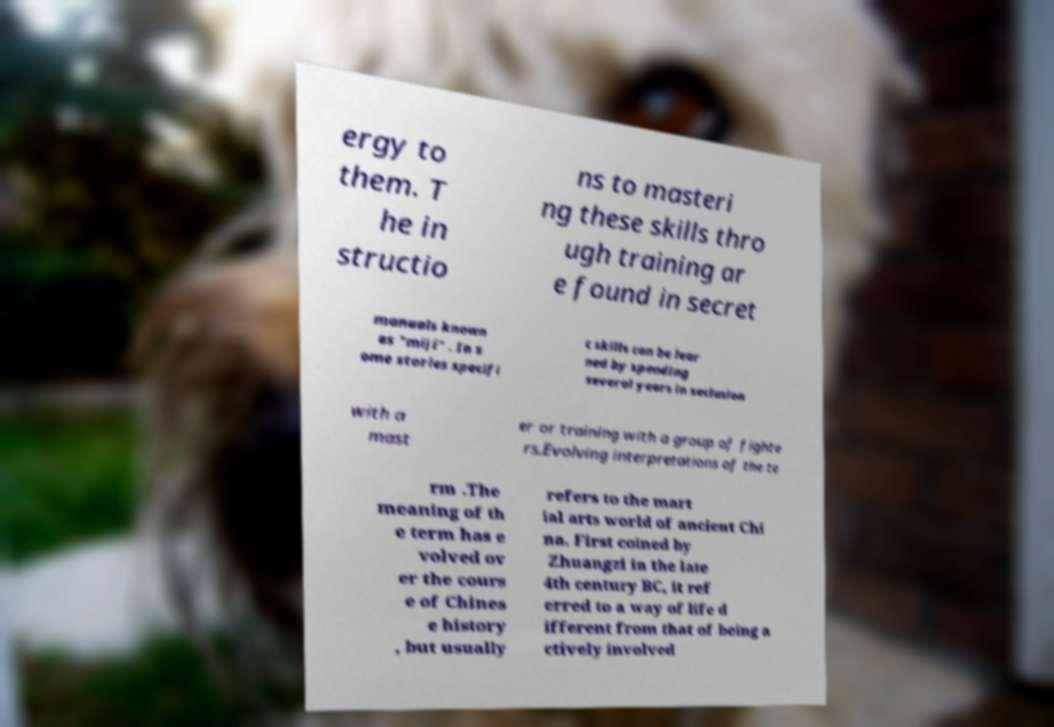What messages or text are displayed in this image? I need them in a readable, typed format. ergy to them. T he in structio ns to masteri ng these skills thro ugh training ar e found in secret manuals known as "miji" . In s ome stories specifi c skills can be lear ned by spending several years in seclusion with a mast er or training with a group of fighte rs.Evolving interpretations of the te rm .The meaning of th e term has e volved ov er the cours e of Chines e history , but usually refers to the mart ial arts world of ancient Chi na. First coined by Zhuangzi in the late 4th century BC, it ref erred to a way of life d ifferent from that of being a ctively involved 